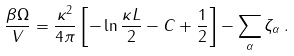<formula> <loc_0><loc_0><loc_500><loc_500>\frac { \beta \Omega } { V } = \frac { \kappa ^ { 2 } } { 4 \pi } \left [ - \ln \frac { \kappa L } { 2 } - C + \frac { 1 } { 2 } \right ] - \sum _ { \alpha } \zeta _ { \alpha } \, .</formula> 